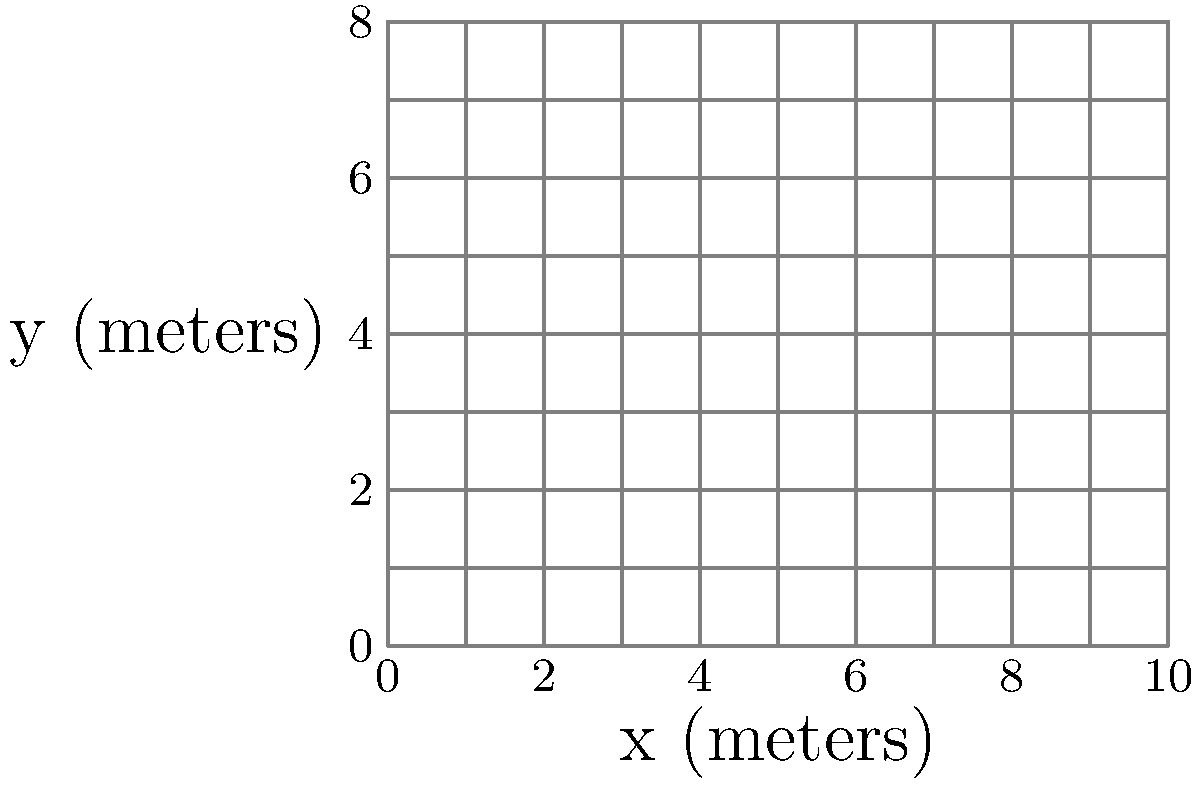An archaeological excavation site is represented by a rectangular area measuring 10 meters by 8 meters. The density of artifacts at any point (x, y) in the site is given by the function:

$$f(x,y) = 0.1x + 0.2y - 0.005xy$$

where x and y are measured in meters from the southwest corner of the site. To maximize the efficiency of the excavation, you need to determine the point of highest artifact density. Use calculus to find the coordinates (x, y) of this point within the excavation site. To find the point of highest artifact density, we need to locate the maximum of the function $f(x,y)$ within the given boundaries. We'll use the following steps:

1. Find the partial derivatives of $f(x,y)$ with respect to x and y:
   $$\frac{\partial f}{\partial x} = 0.1 - 0.005y$$
   $$\frac{\partial f}{\partial y} = 0.2 - 0.005x$$

2. Set both partial derivatives to zero to find critical points:
   $$0.1 - 0.005y = 0$$
   $$0.2 - 0.005x = 0$$

3. Solve these equations:
   $$y = 20$$
   $$x = 40$$

4. The critical point (40, 20) is outside our excavation site boundaries (10m x 8m). Therefore, the maximum must occur on the boundary.

5. Examine the function along each edge of the rectangular site:
   - Bottom edge (y = 0): $f(x,0) = 0.1x$, max at x = 10
   - Top edge (y = 8): $f(x,8) = 0.1x + 1.6 - 0.04x = 1.6 + 0.06x$, max at x = 10
   - Left edge (x = 0): $f(0,y) = 0.2y$, max at y = 8
   - Right edge (x = 10): $f(10,y) = 1 + 0.2y - 0.05y = 1 + 0.15y$, max at y = 8

6. Evaluate $f(x,y)$ at the corners:
   - $f(0,0) = 0$
   - $f(10,0) = 1$
   - $f(0,8) = 1.6$
   - $f(10,8) = 2.2$

The maximum value occurs at the point (10, 8), which is the northeast corner of the excavation site.
Answer: (10, 8) 